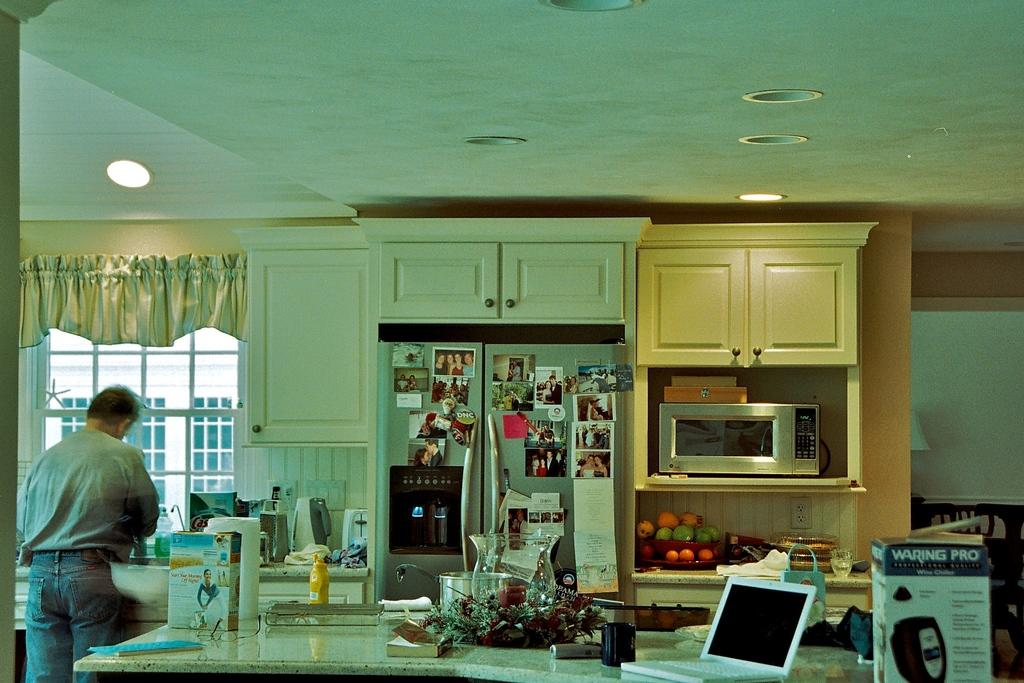Provide a one-sentence caption for the provided image. A cluttered kitchen has a DNC button displayed among many photos and notes on the refrigerator. 